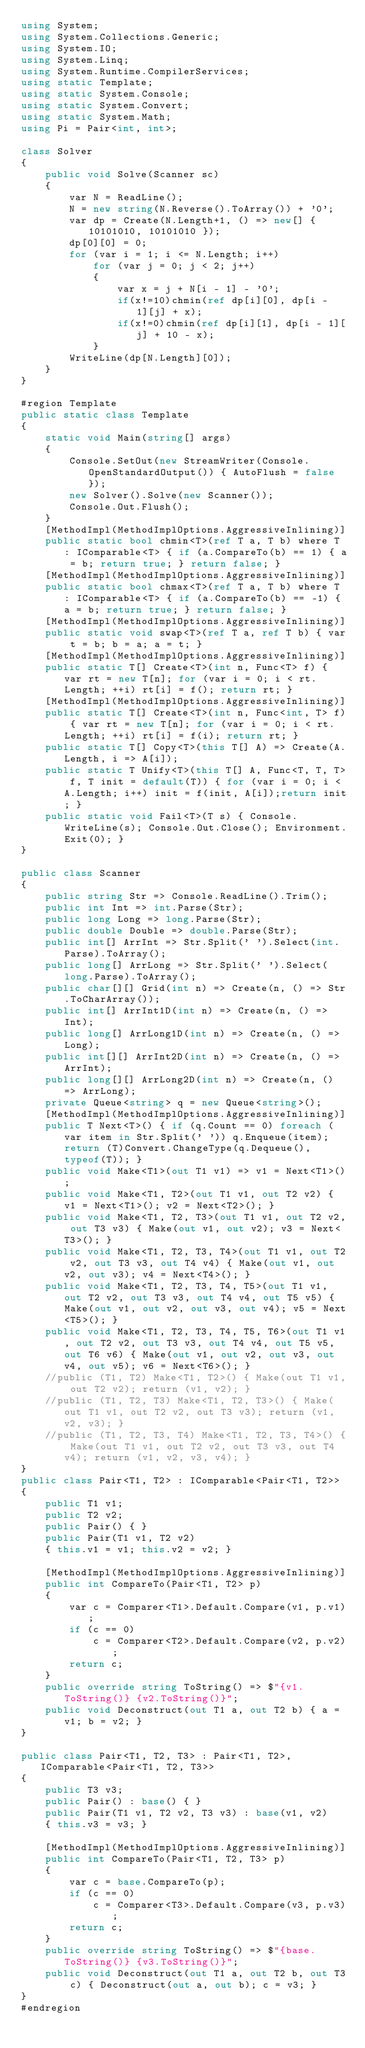Convert code to text. <code><loc_0><loc_0><loc_500><loc_500><_C#_>using System;
using System.Collections.Generic;
using System.IO;
using System.Linq;
using System.Runtime.CompilerServices;
using static Template;
using static System.Console;
using static System.Convert;
using static System.Math;
using Pi = Pair<int, int>;

class Solver
{
    public void Solve(Scanner sc)
    {
        var N = ReadLine();
        N = new string(N.Reverse().ToArray()) + '0';
        var dp = Create(N.Length+1, () => new[] { 10101010, 10101010 });
        dp[0][0] = 0;
        for (var i = 1; i <= N.Length; i++)
            for (var j = 0; j < 2; j++)
            {
                var x = j + N[i - 1] - '0';
                if(x!=10)chmin(ref dp[i][0], dp[i - 1][j] + x);
                if(x!=0)chmin(ref dp[i][1], dp[i - 1][j] + 10 - x);
            }
        WriteLine(dp[N.Length][0]);
    }
}

#region Template
public static class Template
{
    static void Main(string[] args)
    {
        Console.SetOut(new StreamWriter(Console.OpenStandardOutput()) { AutoFlush = false });
        new Solver().Solve(new Scanner());
        Console.Out.Flush();
    }
    [MethodImpl(MethodImplOptions.AggressiveInlining)]
    public static bool chmin<T>(ref T a, T b) where T : IComparable<T> { if (a.CompareTo(b) == 1) { a = b; return true; } return false; }
    [MethodImpl(MethodImplOptions.AggressiveInlining)]
    public static bool chmax<T>(ref T a, T b) where T : IComparable<T> { if (a.CompareTo(b) == -1) { a = b; return true; } return false; }
    [MethodImpl(MethodImplOptions.AggressiveInlining)]
    public static void swap<T>(ref T a, ref T b) { var t = b; b = a; a = t; }
    [MethodImpl(MethodImplOptions.AggressiveInlining)]
    public static T[] Create<T>(int n, Func<T> f) { var rt = new T[n]; for (var i = 0; i < rt.Length; ++i) rt[i] = f(); return rt; }
    [MethodImpl(MethodImplOptions.AggressiveInlining)]
    public static T[] Create<T>(int n, Func<int, T> f) { var rt = new T[n]; for (var i = 0; i < rt.Length; ++i) rt[i] = f(i); return rt; }
    public static T[] Copy<T>(this T[] A) => Create(A.Length, i => A[i]);
    public static T Unify<T>(this T[] A, Func<T, T, T> f, T init = default(T)) { for (var i = 0; i < A.Length; i++) init = f(init, A[i]);return init; }
    public static void Fail<T>(T s) { Console.WriteLine(s); Console.Out.Close(); Environment.Exit(0); }
}

public class Scanner
{
    public string Str => Console.ReadLine().Trim();
    public int Int => int.Parse(Str);
    public long Long => long.Parse(Str);
    public double Double => double.Parse(Str);
    public int[] ArrInt => Str.Split(' ').Select(int.Parse).ToArray();
    public long[] ArrLong => Str.Split(' ').Select(long.Parse).ToArray();
    public char[][] Grid(int n) => Create(n, () => Str.ToCharArray());
    public int[] ArrInt1D(int n) => Create(n, () => Int);
    public long[] ArrLong1D(int n) => Create(n, () => Long);
    public int[][] ArrInt2D(int n) => Create(n, () => ArrInt);
    public long[][] ArrLong2D(int n) => Create(n, () => ArrLong);
    private Queue<string> q = new Queue<string>();
    [MethodImpl(MethodImplOptions.AggressiveInlining)]
    public T Next<T>() { if (q.Count == 0) foreach (var item in Str.Split(' ')) q.Enqueue(item); return (T)Convert.ChangeType(q.Dequeue(), typeof(T)); }
    public void Make<T1>(out T1 v1) => v1 = Next<T1>();
    public void Make<T1, T2>(out T1 v1, out T2 v2) { v1 = Next<T1>(); v2 = Next<T2>(); }
    public void Make<T1, T2, T3>(out T1 v1, out T2 v2, out T3 v3) { Make(out v1, out v2); v3 = Next<T3>(); }
    public void Make<T1, T2, T3, T4>(out T1 v1, out T2 v2, out T3 v3, out T4 v4) { Make(out v1, out v2, out v3); v4 = Next<T4>(); }
    public void Make<T1, T2, T3, T4, T5>(out T1 v1, out T2 v2, out T3 v3, out T4 v4, out T5 v5) { Make(out v1, out v2, out v3, out v4); v5 = Next<T5>(); }
    public void Make<T1, T2, T3, T4, T5, T6>(out T1 v1, out T2 v2, out T3 v3, out T4 v4, out T5 v5, out T6 v6) { Make(out v1, out v2, out v3, out v4, out v5); v6 = Next<T6>(); }
    //public (T1, T2) Make<T1, T2>() { Make(out T1 v1, out T2 v2); return (v1, v2); }
    //public (T1, T2, T3) Make<T1, T2, T3>() { Make(out T1 v1, out T2 v2, out T3 v3); return (v1, v2, v3); }
    //public (T1, T2, T3, T4) Make<T1, T2, T3, T4>() { Make(out T1 v1, out T2 v2, out T3 v3, out T4 v4); return (v1, v2, v3, v4); }
}
public class Pair<T1, T2> : IComparable<Pair<T1, T2>>
{
    public T1 v1;
    public T2 v2;
    public Pair() { }
    public Pair(T1 v1, T2 v2)
    { this.v1 = v1; this.v2 = v2; }

    [MethodImpl(MethodImplOptions.AggressiveInlining)]
    public int CompareTo(Pair<T1, T2> p)
    {
        var c = Comparer<T1>.Default.Compare(v1, p.v1);
        if (c == 0)
            c = Comparer<T2>.Default.Compare(v2, p.v2);
        return c;
    }
    public override string ToString() => $"{v1.ToString()} {v2.ToString()}";
    public void Deconstruct(out T1 a, out T2 b) { a = v1; b = v2; }
}

public class Pair<T1, T2, T3> : Pair<T1, T2>, IComparable<Pair<T1, T2, T3>>
{
    public T3 v3;
    public Pair() : base() { }
    public Pair(T1 v1, T2 v2, T3 v3) : base(v1, v2)
    { this.v3 = v3; }

    [MethodImpl(MethodImplOptions.AggressiveInlining)]
    public int CompareTo(Pair<T1, T2, T3> p)
    {
        var c = base.CompareTo(p);
        if (c == 0)
            c = Comparer<T3>.Default.Compare(v3, p.v3);
        return c;
    }
    public override string ToString() => $"{base.ToString()} {v3.ToString()}";
    public void Deconstruct(out T1 a, out T2 b, out T3 c) { Deconstruct(out a, out b); c = v3; }
}
#endregion</code> 